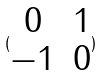Convert formula to latex. <formula><loc_0><loc_0><loc_500><loc_500>( \begin{matrix} 0 & 1 \\ - 1 & 0 \end{matrix} )</formula> 